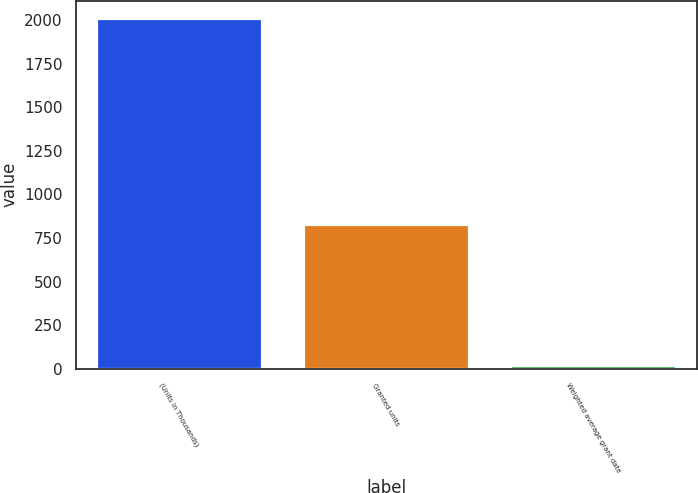<chart> <loc_0><loc_0><loc_500><loc_500><bar_chart><fcel>(Units in Thousands)<fcel>Granted units<fcel>Weighted average grant date<nl><fcel>2011<fcel>828<fcel>23.63<nl></chart> 